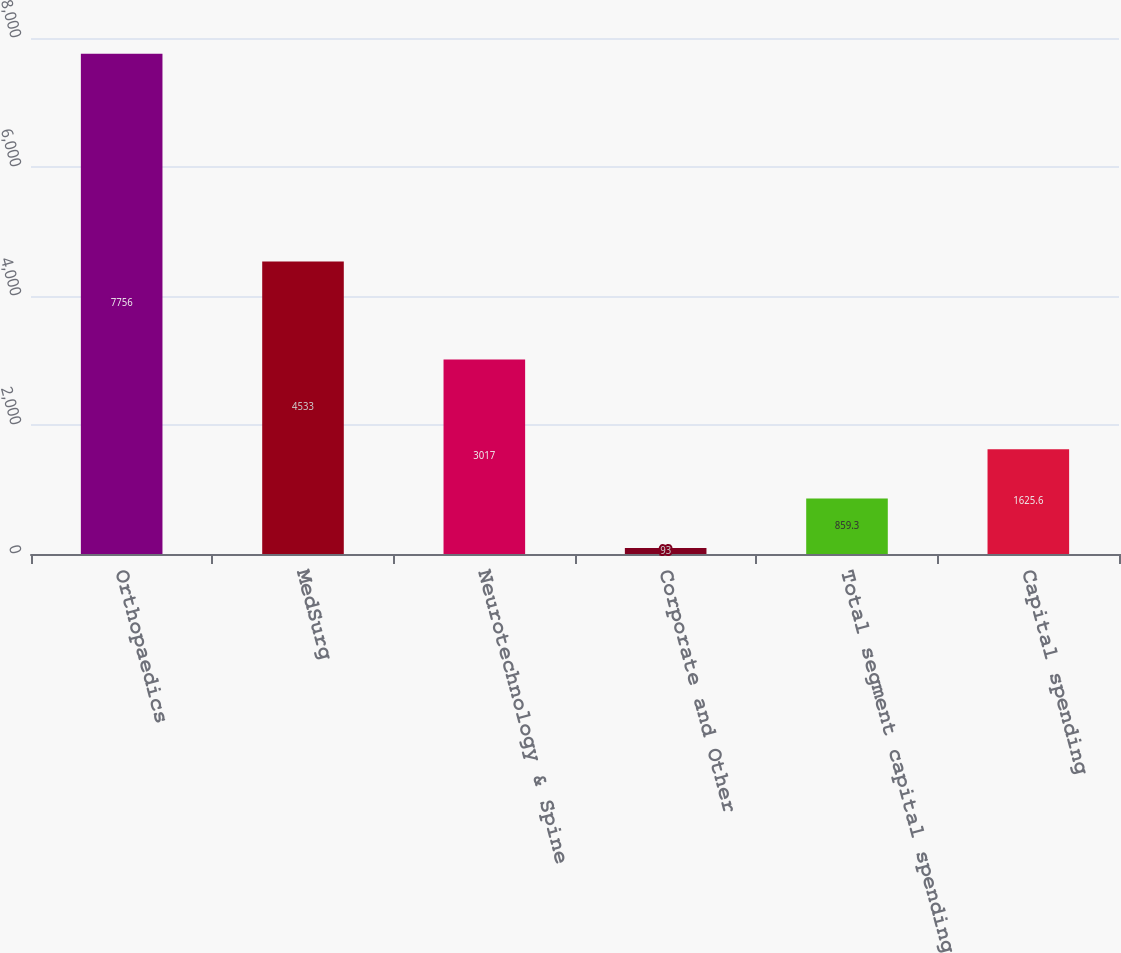Convert chart. <chart><loc_0><loc_0><loc_500><loc_500><bar_chart><fcel>Orthopaedics<fcel>MedSurg<fcel>Neurotechnology & Spine<fcel>Corporate and Other<fcel>Total segment capital spending<fcel>Capital spending<nl><fcel>7756<fcel>4533<fcel>3017<fcel>93<fcel>859.3<fcel>1625.6<nl></chart> 